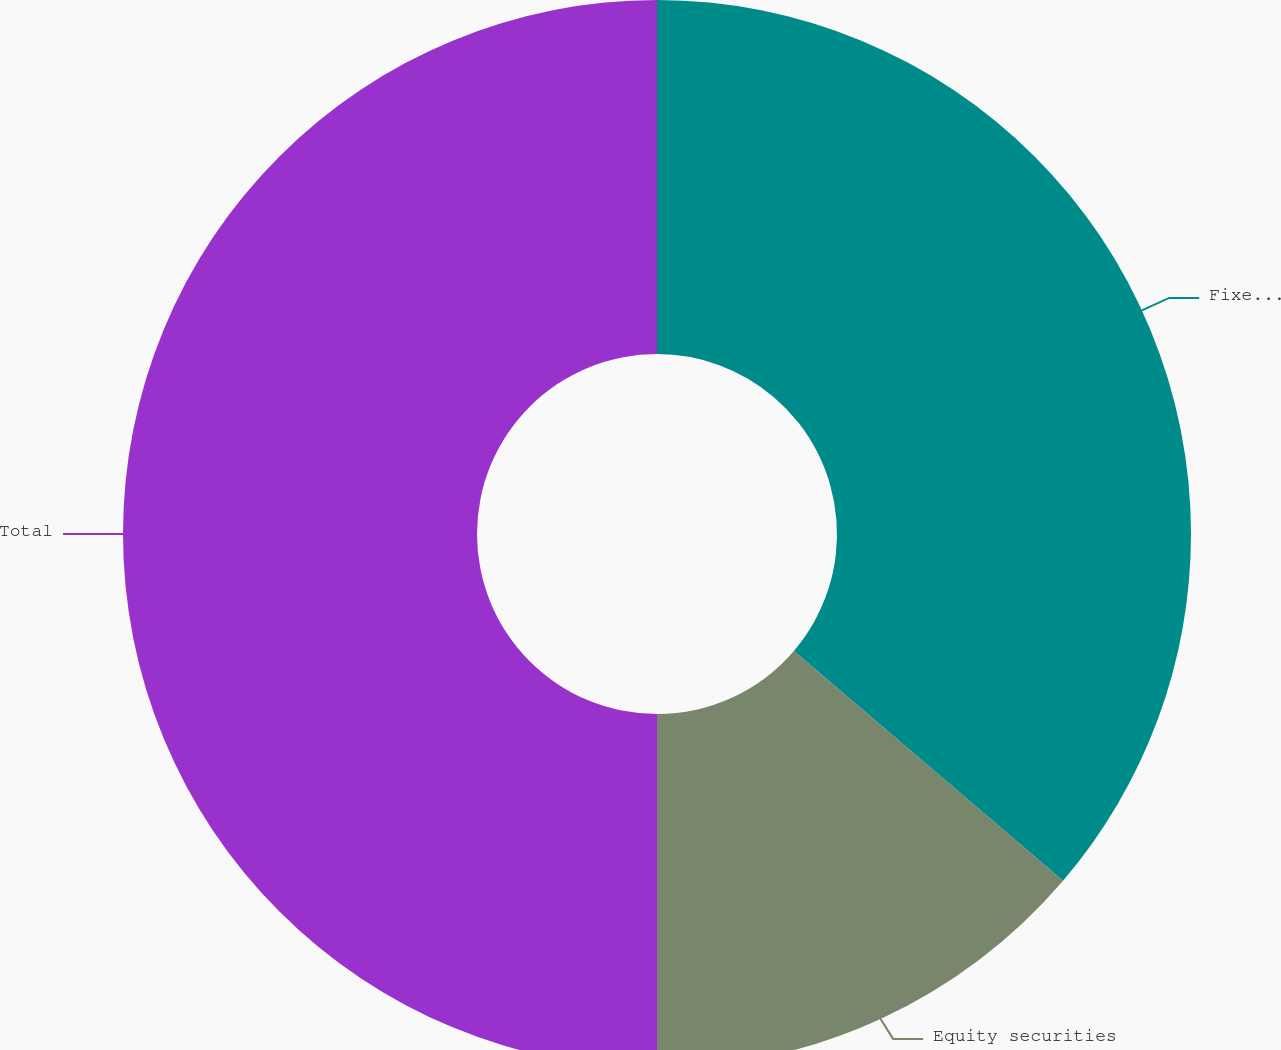<chart> <loc_0><loc_0><loc_500><loc_500><pie_chart><fcel>Fixed maturities<fcel>Equity securities<fcel>Total<nl><fcel>36.25%<fcel>13.75%<fcel>50.0%<nl></chart> 